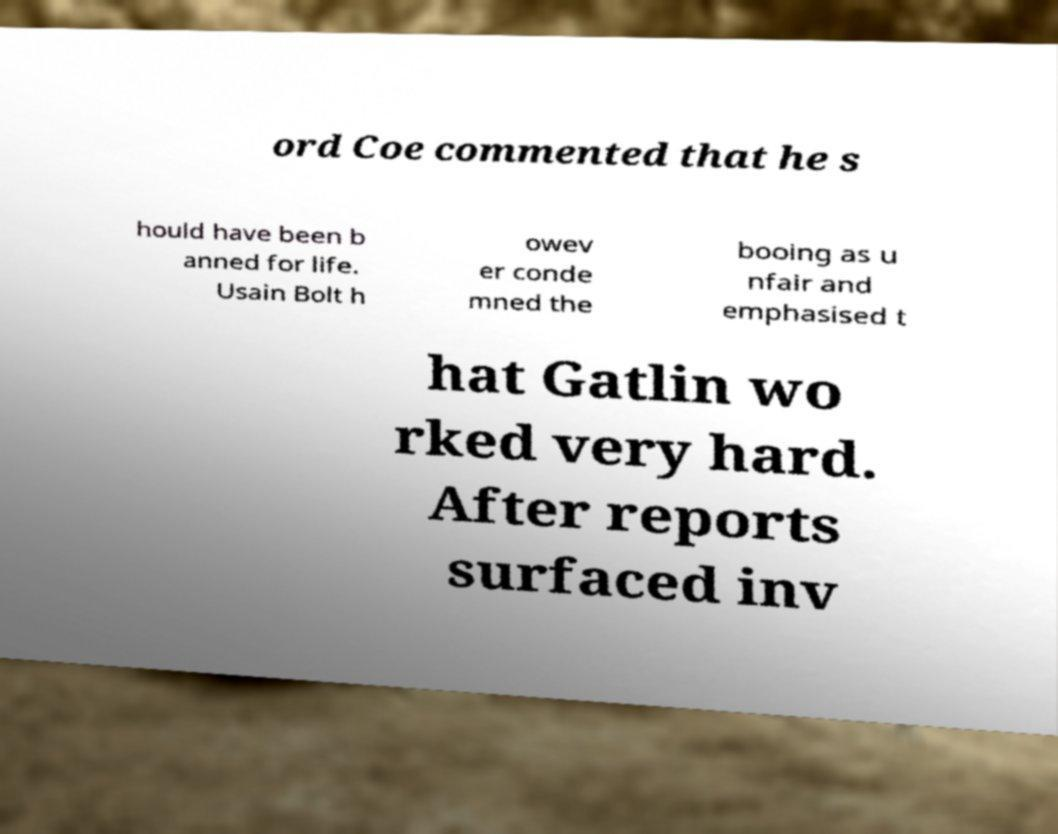Please read and relay the text visible in this image. What does it say? ord Coe commented that he s hould have been b anned for life. Usain Bolt h owev er conde mned the booing as u nfair and emphasised t hat Gatlin wo rked very hard. After reports surfaced inv 